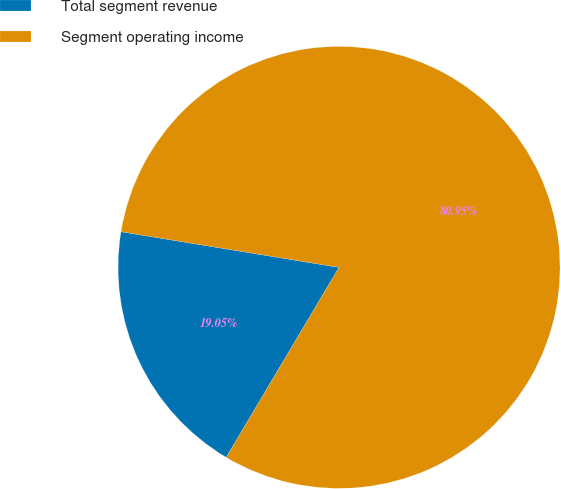Convert chart to OTSL. <chart><loc_0><loc_0><loc_500><loc_500><pie_chart><fcel>Total segment revenue<fcel>Segment operating income<nl><fcel>19.05%<fcel>80.95%<nl></chart> 